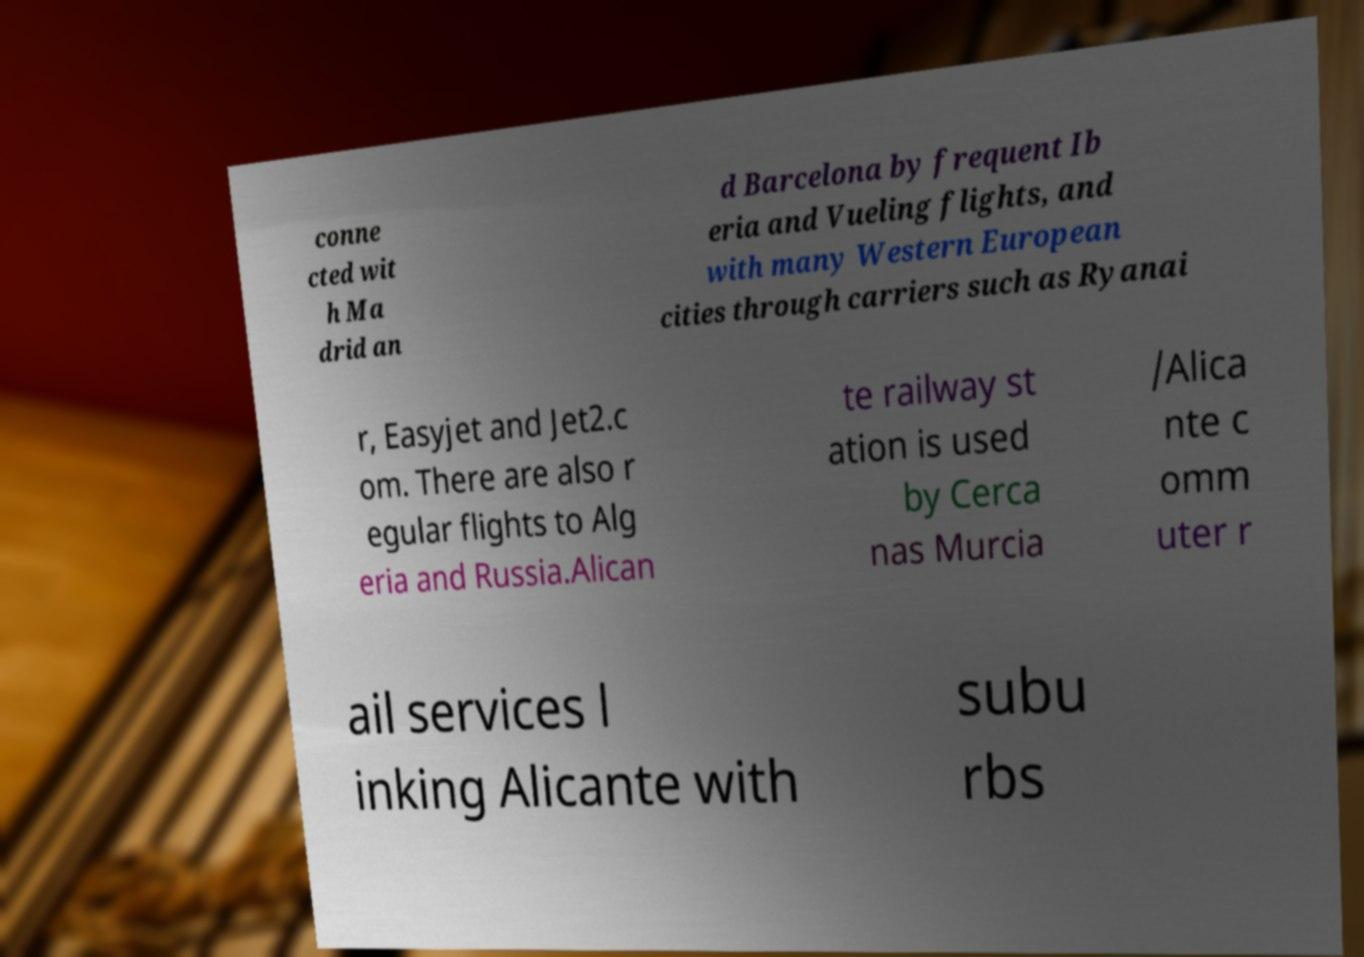Could you extract and type out the text from this image? conne cted wit h Ma drid an d Barcelona by frequent Ib eria and Vueling flights, and with many Western European cities through carriers such as Ryanai r, Easyjet and Jet2.c om. There are also r egular flights to Alg eria and Russia.Alican te railway st ation is used by Cerca nas Murcia /Alica nte c omm uter r ail services l inking Alicante with subu rbs 